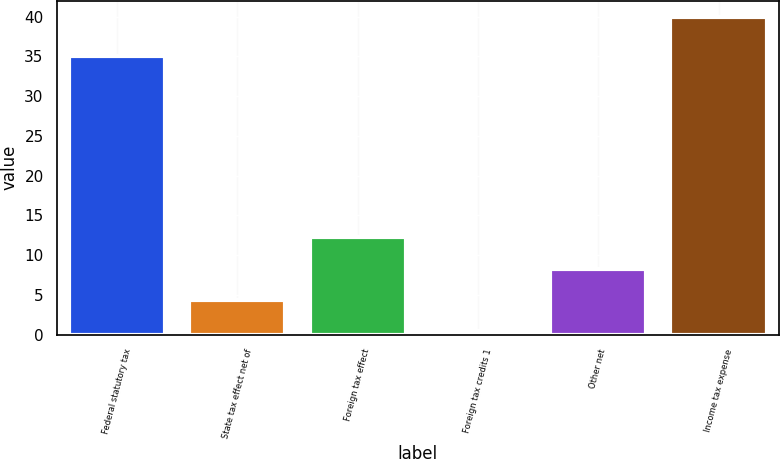Convert chart. <chart><loc_0><loc_0><loc_500><loc_500><bar_chart><fcel>Federal statutory tax<fcel>State tax effect net of<fcel>Foreign tax effect<fcel>Foreign tax credits 1<fcel>Other net<fcel>Income tax expense<nl><fcel>35<fcel>4.36<fcel>12.28<fcel>0.4<fcel>8.32<fcel>40<nl></chart> 